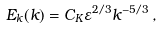<formula> <loc_0><loc_0><loc_500><loc_500>E _ { k } ( k ) = C _ { K } \varepsilon ^ { 2 / 3 } k ^ { - 5 / 3 } \, ,</formula> 